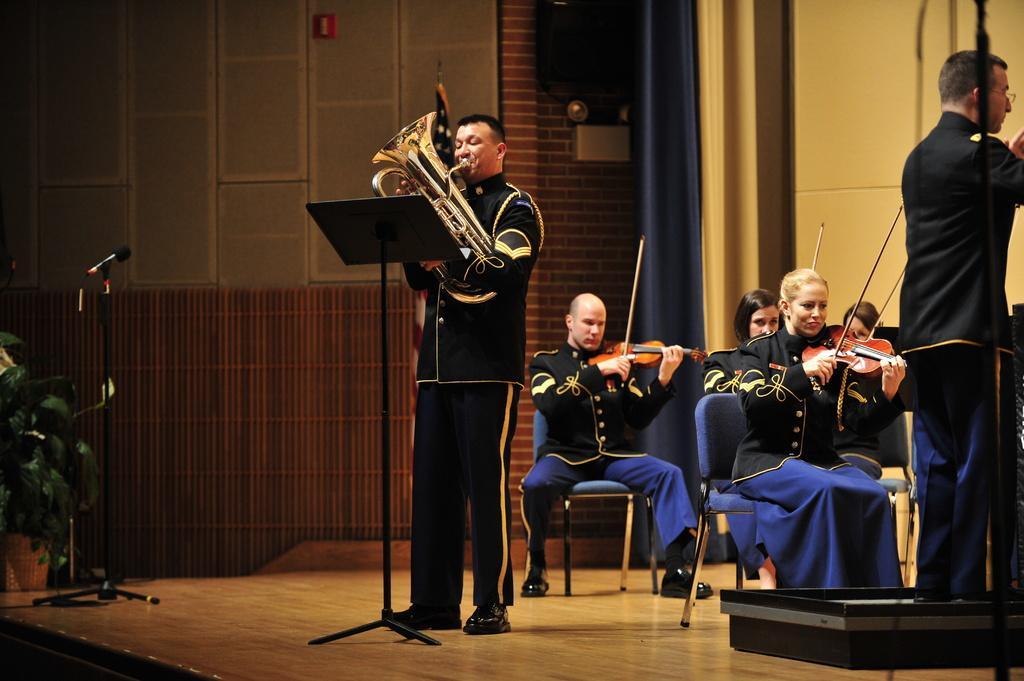How would you summarize this image in a sentence or two? In the image we can see two persons were standing and holding saxophone. And the four persons were sitting on the chair and holding violin. In front there is a microphone. In the background there is a wall,curtain and plant. 